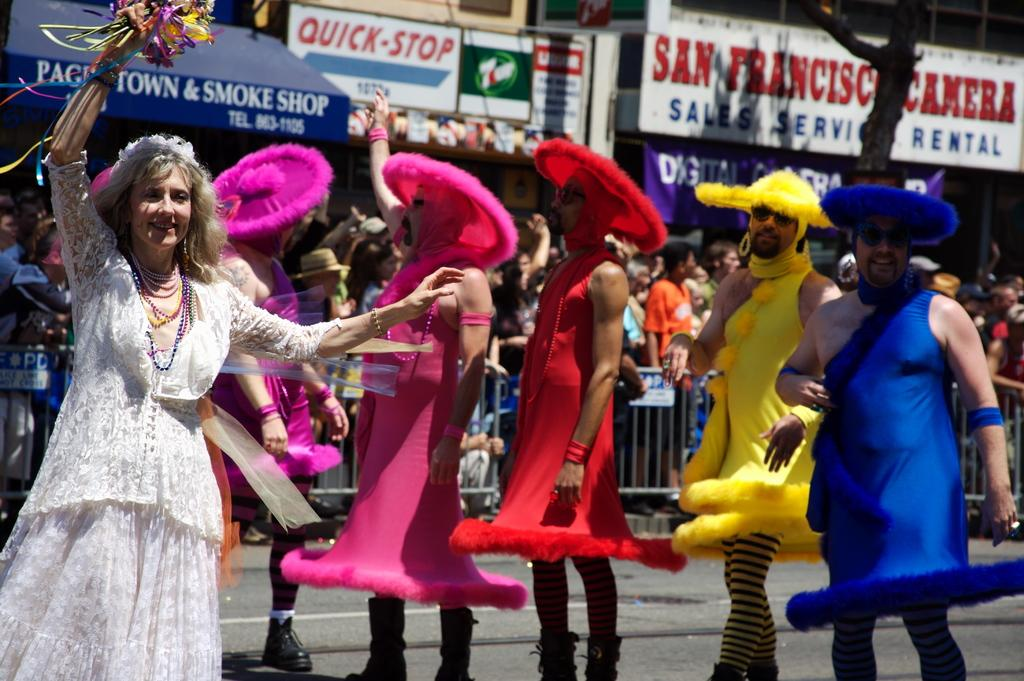What are the people in the image wearing? The people in the image are wearing costumes. Can you describe what one person is holding? One person is holding flowers. What can be seen in the background of the image? In the background of the image, there are people, railings, a tree, boards, and a banner. What type of event is being held in the image? There is no specific event mentioned or depicted in the image. 